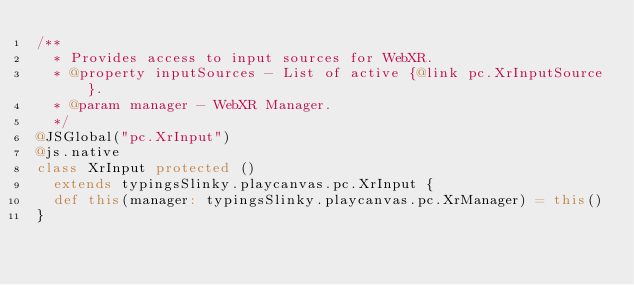Convert code to text. <code><loc_0><loc_0><loc_500><loc_500><_Scala_>/**
  * Provides access to input sources for WebXR.
  * @property inputSources - List of active {@link pc.XrInputSource}.
  * @param manager - WebXR Manager.
  */
@JSGlobal("pc.XrInput")
@js.native
class XrInput protected ()
  extends typingsSlinky.playcanvas.pc.XrInput {
  def this(manager: typingsSlinky.playcanvas.pc.XrManager) = this()
}
</code> 